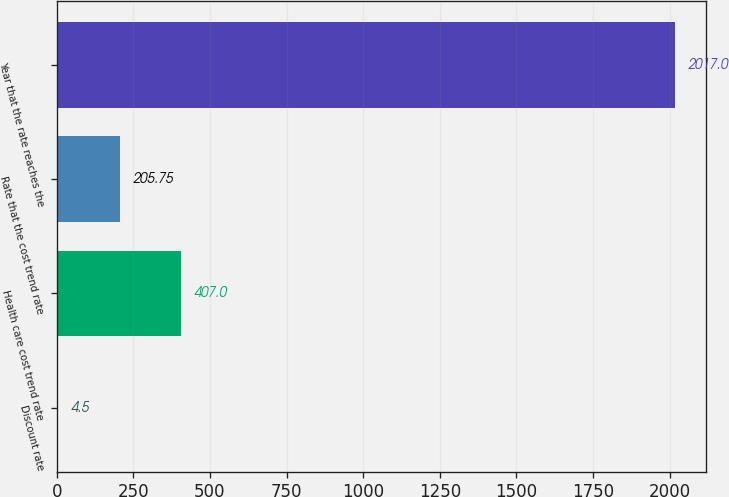Convert chart to OTSL. <chart><loc_0><loc_0><loc_500><loc_500><bar_chart><fcel>Discount rate<fcel>Health care cost trend rate<fcel>Rate that the cost trend rate<fcel>Year that the rate reaches the<nl><fcel>4.5<fcel>407<fcel>205.75<fcel>2017<nl></chart> 